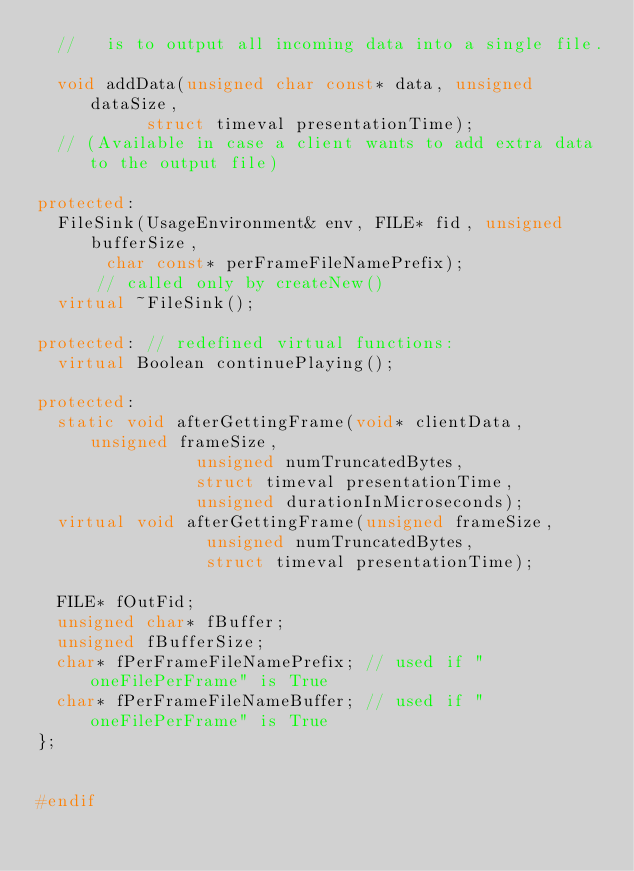<code> <loc_0><loc_0><loc_500><loc_500><_C++_>  //   is to output all incoming data into a single file.

  void addData(unsigned char const* data, unsigned dataSize,
	       struct timeval presentationTime);
  // (Available in case a client wants to add extra data to the output file)

protected:
  FileSink(UsageEnvironment& env, FILE* fid, unsigned bufferSize,
	   char const* perFrameFileNamePrefix);
      // called only by createNew()
  virtual ~FileSink();

protected: // redefined virtual functions:
  virtual Boolean continuePlaying();

protected:
  static void afterGettingFrame(void* clientData, unsigned frameSize,
				unsigned numTruncatedBytes,
				struct timeval presentationTime,
				unsigned durationInMicroseconds);
  virtual void afterGettingFrame(unsigned frameSize,
				 unsigned numTruncatedBytes,
				 struct timeval presentationTime);

  FILE* fOutFid;
  unsigned char* fBuffer;
  unsigned fBufferSize;
  char* fPerFrameFileNamePrefix; // used if "oneFilePerFrame" is True
  char* fPerFrameFileNameBuffer; // used if "oneFilePerFrame" is True
};


#endif
</code> 